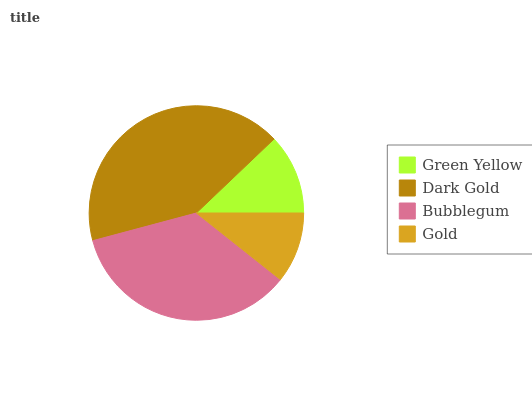Is Gold the minimum?
Answer yes or no. Yes. Is Dark Gold the maximum?
Answer yes or no. Yes. Is Bubblegum the minimum?
Answer yes or no. No. Is Bubblegum the maximum?
Answer yes or no. No. Is Dark Gold greater than Bubblegum?
Answer yes or no. Yes. Is Bubblegum less than Dark Gold?
Answer yes or no. Yes. Is Bubblegum greater than Dark Gold?
Answer yes or no. No. Is Dark Gold less than Bubblegum?
Answer yes or no. No. Is Bubblegum the high median?
Answer yes or no. Yes. Is Green Yellow the low median?
Answer yes or no. Yes. Is Gold the high median?
Answer yes or no. No. Is Gold the low median?
Answer yes or no. No. 